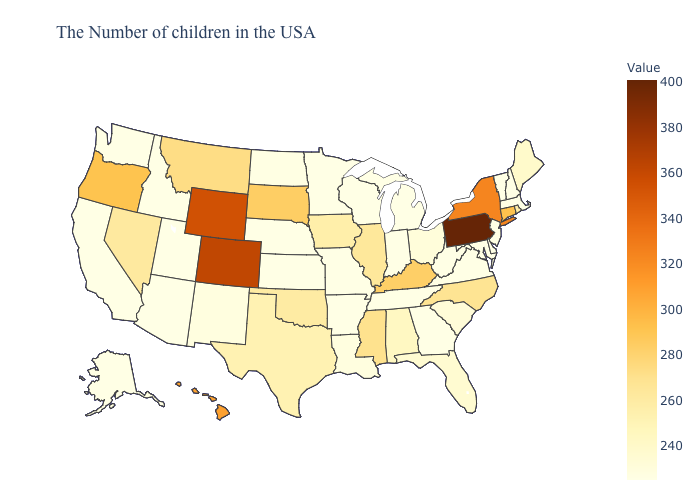Does the map have missing data?
Write a very short answer. No. Does the map have missing data?
Concise answer only. No. Is the legend a continuous bar?
Be succinct. Yes. Among the states that border California , does Oregon have the highest value?
Quick response, please. Yes. Among the states that border Arkansas , which have the lowest value?
Give a very brief answer. Tennessee, Missouri. Does Michigan have the highest value in the USA?
Quick response, please. No. 